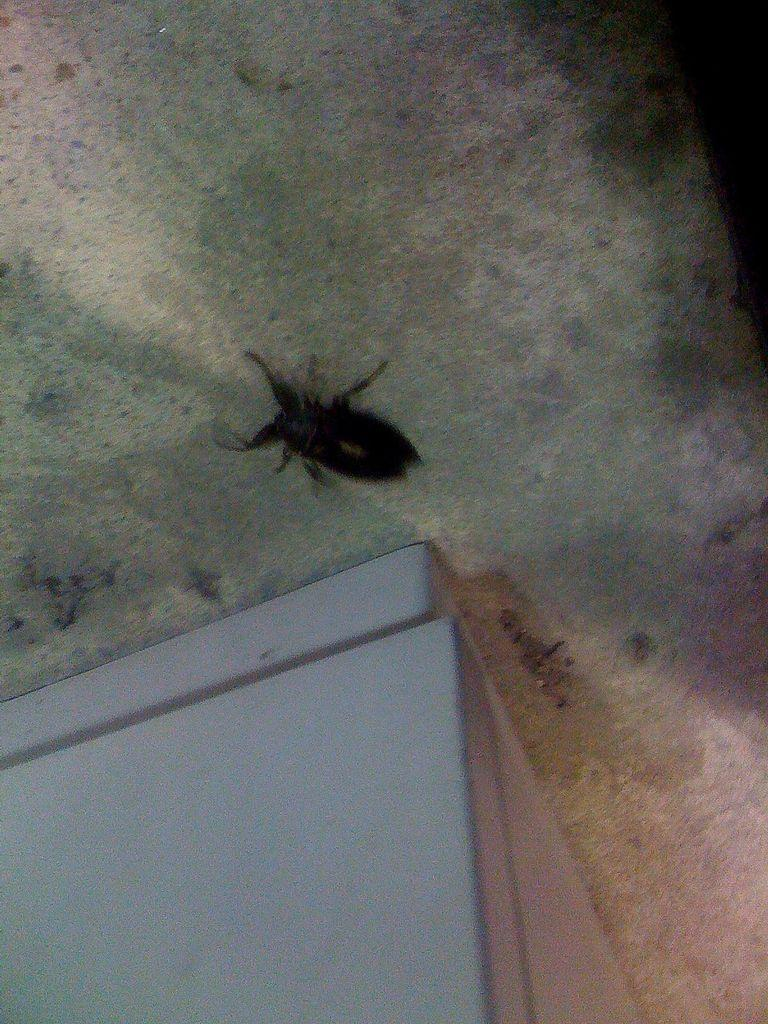What type of creature can be seen in the image? There is an insect in the image. What color is the object in the image? The object in the image is white. Can you see a verse written on the seashore in the image? There is no seashore or verse present in the image; it only features an insect and a white object. 